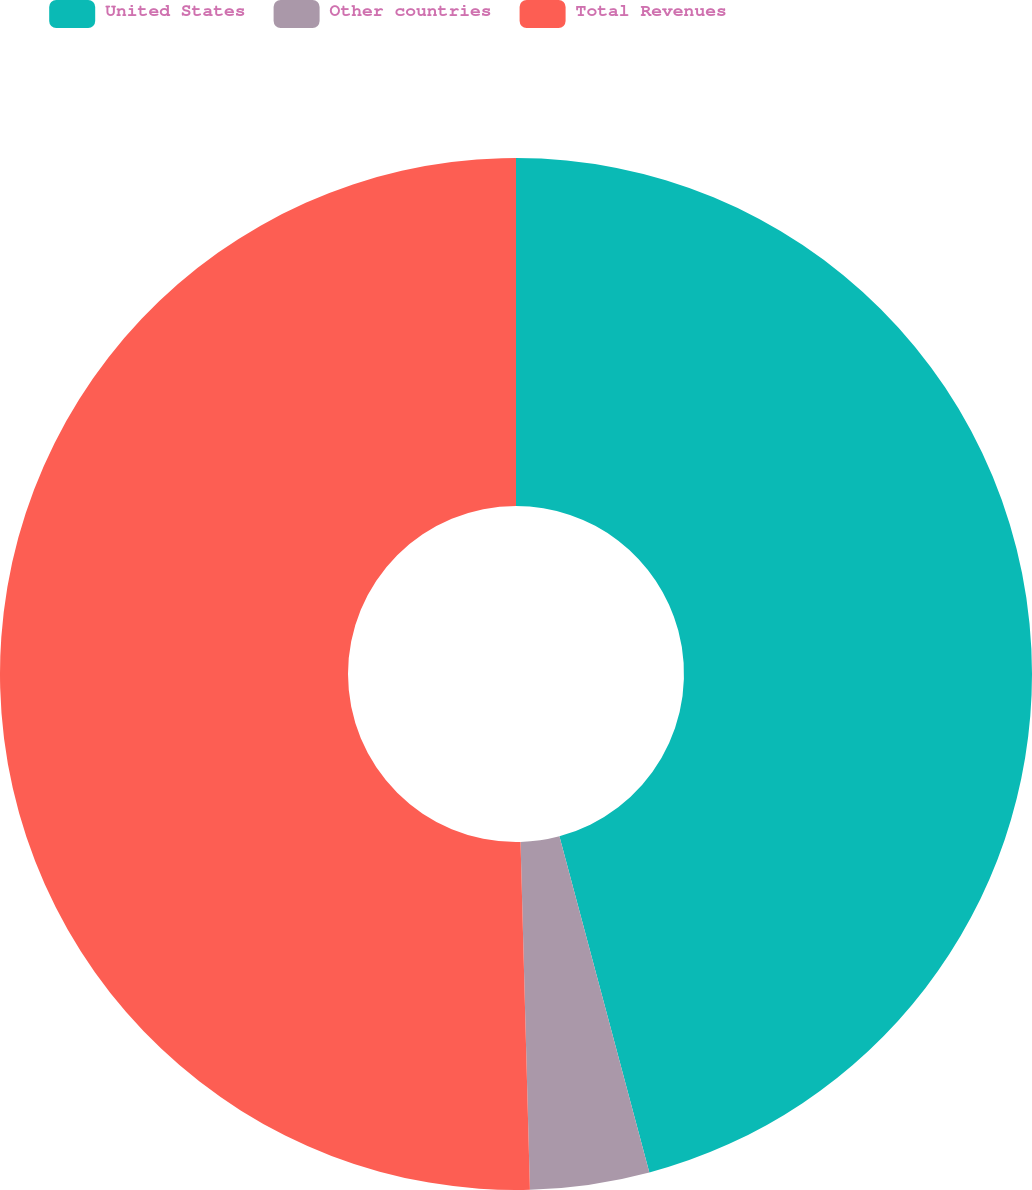Convert chart. <chart><loc_0><loc_0><loc_500><loc_500><pie_chart><fcel>United States<fcel>Other countries<fcel>Total Revenues<nl><fcel>45.84%<fcel>3.73%<fcel>50.43%<nl></chart> 